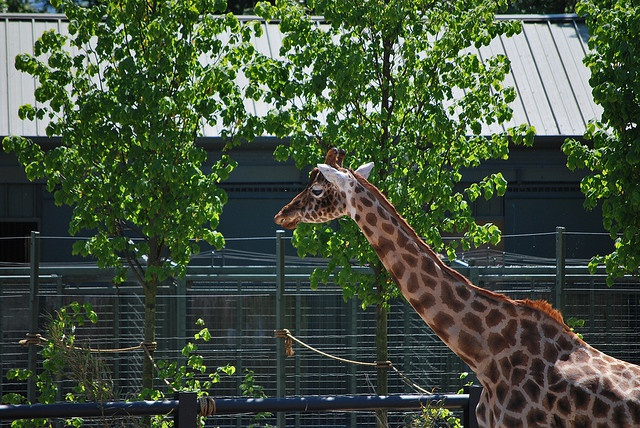Describe the objects in this image and their specific colors. I can see a giraffe in green, black, gray, and maroon tones in this image. 